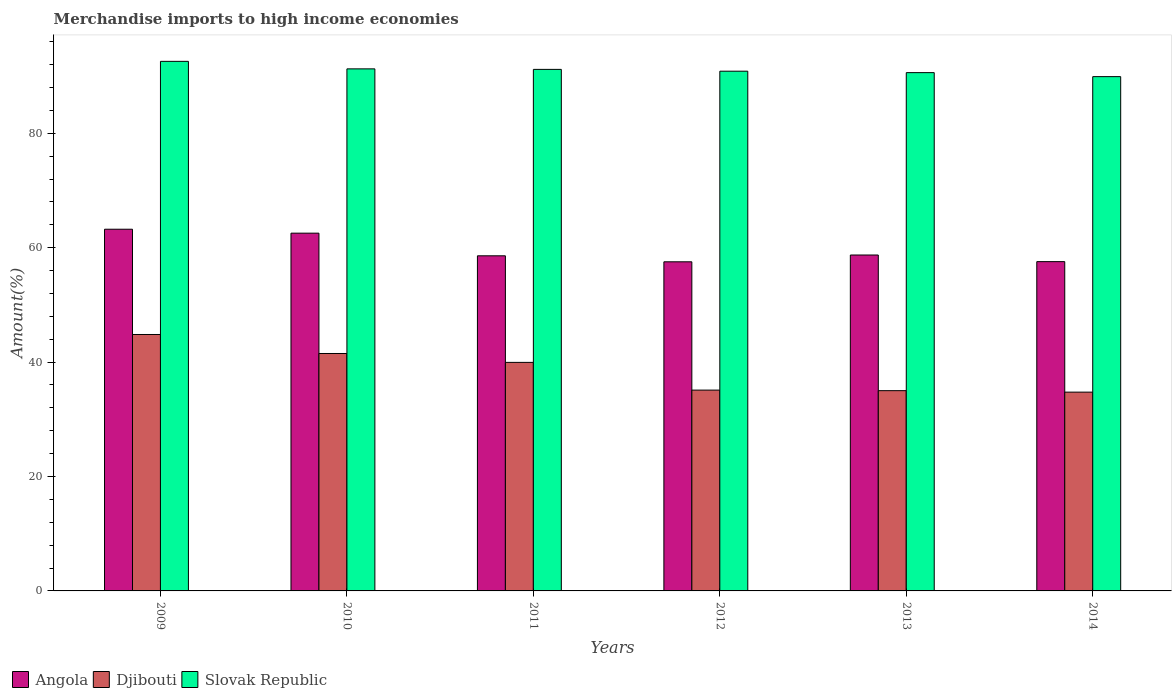How many different coloured bars are there?
Offer a terse response. 3. Are the number of bars per tick equal to the number of legend labels?
Your response must be concise. Yes. Are the number of bars on each tick of the X-axis equal?
Offer a very short reply. Yes. What is the label of the 1st group of bars from the left?
Make the answer very short. 2009. In how many cases, is the number of bars for a given year not equal to the number of legend labels?
Keep it short and to the point. 0. What is the percentage of amount earned from merchandise imports in Slovak Republic in 2013?
Give a very brief answer. 90.61. Across all years, what is the maximum percentage of amount earned from merchandise imports in Slovak Republic?
Make the answer very short. 92.58. Across all years, what is the minimum percentage of amount earned from merchandise imports in Slovak Republic?
Provide a short and direct response. 89.91. In which year was the percentage of amount earned from merchandise imports in Djibouti maximum?
Provide a short and direct response. 2009. In which year was the percentage of amount earned from merchandise imports in Angola minimum?
Ensure brevity in your answer.  2012. What is the total percentage of amount earned from merchandise imports in Angola in the graph?
Make the answer very short. 358.18. What is the difference between the percentage of amount earned from merchandise imports in Angola in 2009 and that in 2012?
Give a very brief answer. 5.7. What is the difference between the percentage of amount earned from merchandise imports in Angola in 2011 and the percentage of amount earned from merchandise imports in Slovak Republic in 2013?
Give a very brief answer. -32.02. What is the average percentage of amount earned from merchandise imports in Slovak Republic per year?
Keep it short and to the point. 91.06. In the year 2010, what is the difference between the percentage of amount earned from merchandise imports in Djibouti and percentage of amount earned from merchandise imports in Slovak Republic?
Ensure brevity in your answer.  -49.76. In how many years, is the percentage of amount earned from merchandise imports in Djibouti greater than 48 %?
Ensure brevity in your answer.  0. What is the ratio of the percentage of amount earned from merchandise imports in Angola in 2009 to that in 2013?
Ensure brevity in your answer.  1.08. Is the percentage of amount earned from merchandise imports in Djibouti in 2010 less than that in 2014?
Make the answer very short. No. Is the difference between the percentage of amount earned from merchandise imports in Djibouti in 2010 and 2012 greater than the difference between the percentage of amount earned from merchandise imports in Slovak Republic in 2010 and 2012?
Your response must be concise. Yes. What is the difference between the highest and the second highest percentage of amount earned from merchandise imports in Djibouti?
Make the answer very short. 3.32. What is the difference between the highest and the lowest percentage of amount earned from merchandise imports in Angola?
Offer a terse response. 5.7. What does the 1st bar from the left in 2010 represents?
Your answer should be very brief. Angola. What does the 2nd bar from the right in 2010 represents?
Your response must be concise. Djibouti. What is the difference between two consecutive major ticks on the Y-axis?
Provide a succinct answer. 20. Does the graph contain any zero values?
Provide a succinct answer. No. Does the graph contain grids?
Your answer should be very brief. No. How many legend labels are there?
Give a very brief answer. 3. How are the legend labels stacked?
Your response must be concise. Horizontal. What is the title of the graph?
Ensure brevity in your answer.  Merchandise imports to high income economies. Does "Sweden" appear as one of the legend labels in the graph?
Give a very brief answer. No. What is the label or title of the X-axis?
Your answer should be very brief. Years. What is the label or title of the Y-axis?
Your answer should be very brief. Amount(%). What is the Amount(%) in Angola in 2009?
Your response must be concise. 63.23. What is the Amount(%) of Djibouti in 2009?
Give a very brief answer. 44.83. What is the Amount(%) in Slovak Republic in 2009?
Ensure brevity in your answer.  92.58. What is the Amount(%) in Angola in 2010?
Your answer should be very brief. 62.54. What is the Amount(%) of Djibouti in 2010?
Offer a terse response. 41.51. What is the Amount(%) in Slovak Republic in 2010?
Your answer should be compact. 91.26. What is the Amount(%) of Angola in 2011?
Provide a short and direct response. 58.58. What is the Amount(%) in Djibouti in 2011?
Your answer should be compact. 39.95. What is the Amount(%) of Slovak Republic in 2011?
Your answer should be compact. 91.17. What is the Amount(%) of Angola in 2012?
Ensure brevity in your answer.  57.53. What is the Amount(%) in Djibouti in 2012?
Give a very brief answer. 35.11. What is the Amount(%) in Slovak Republic in 2012?
Offer a terse response. 90.86. What is the Amount(%) of Angola in 2013?
Provide a short and direct response. 58.72. What is the Amount(%) in Djibouti in 2013?
Offer a very short reply. 35.01. What is the Amount(%) of Slovak Republic in 2013?
Your answer should be compact. 90.61. What is the Amount(%) in Angola in 2014?
Ensure brevity in your answer.  57.57. What is the Amount(%) of Djibouti in 2014?
Keep it short and to the point. 34.75. What is the Amount(%) in Slovak Republic in 2014?
Your answer should be compact. 89.91. Across all years, what is the maximum Amount(%) of Angola?
Your response must be concise. 63.23. Across all years, what is the maximum Amount(%) of Djibouti?
Keep it short and to the point. 44.83. Across all years, what is the maximum Amount(%) in Slovak Republic?
Your response must be concise. 92.58. Across all years, what is the minimum Amount(%) of Angola?
Offer a very short reply. 57.53. Across all years, what is the minimum Amount(%) in Djibouti?
Your answer should be very brief. 34.75. Across all years, what is the minimum Amount(%) of Slovak Republic?
Make the answer very short. 89.91. What is the total Amount(%) in Angola in the graph?
Offer a terse response. 358.18. What is the total Amount(%) in Djibouti in the graph?
Offer a terse response. 231.15. What is the total Amount(%) of Slovak Republic in the graph?
Your answer should be very brief. 546.39. What is the difference between the Amount(%) of Angola in 2009 and that in 2010?
Ensure brevity in your answer.  0.69. What is the difference between the Amount(%) of Djibouti in 2009 and that in 2010?
Give a very brief answer. 3.32. What is the difference between the Amount(%) in Slovak Republic in 2009 and that in 2010?
Provide a short and direct response. 1.31. What is the difference between the Amount(%) of Angola in 2009 and that in 2011?
Make the answer very short. 4.65. What is the difference between the Amount(%) in Djibouti in 2009 and that in 2011?
Your answer should be compact. 4.87. What is the difference between the Amount(%) of Slovak Republic in 2009 and that in 2011?
Give a very brief answer. 1.4. What is the difference between the Amount(%) in Angola in 2009 and that in 2012?
Offer a terse response. 5.7. What is the difference between the Amount(%) in Djibouti in 2009 and that in 2012?
Your response must be concise. 9.72. What is the difference between the Amount(%) of Slovak Republic in 2009 and that in 2012?
Offer a terse response. 1.72. What is the difference between the Amount(%) in Angola in 2009 and that in 2013?
Provide a succinct answer. 4.51. What is the difference between the Amount(%) in Djibouti in 2009 and that in 2013?
Keep it short and to the point. 9.82. What is the difference between the Amount(%) in Slovak Republic in 2009 and that in 2013?
Offer a very short reply. 1.97. What is the difference between the Amount(%) of Angola in 2009 and that in 2014?
Provide a succinct answer. 5.66. What is the difference between the Amount(%) in Djibouti in 2009 and that in 2014?
Make the answer very short. 10.08. What is the difference between the Amount(%) in Slovak Republic in 2009 and that in 2014?
Provide a short and direct response. 2.67. What is the difference between the Amount(%) in Angola in 2010 and that in 2011?
Provide a succinct answer. 3.96. What is the difference between the Amount(%) in Djibouti in 2010 and that in 2011?
Provide a succinct answer. 1.55. What is the difference between the Amount(%) of Slovak Republic in 2010 and that in 2011?
Offer a very short reply. 0.09. What is the difference between the Amount(%) in Angola in 2010 and that in 2012?
Your answer should be compact. 5.01. What is the difference between the Amount(%) of Djibouti in 2010 and that in 2012?
Provide a succinct answer. 6.4. What is the difference between the Amount(%) in Slovak Republic in 2010 and that in 2012?
Give a very brief answer. 0.41. What is the difference between the Amount(%) of Angola in 2010 and that in 2013?
Ensure brevity in your answer.  3.82. What is the difference between the Amount(%) in Djibouti in 2010 and that in 2013?
Your answer should be compact. 6.5. What is the difference between the Amount(%) of Slovak Republic in 2010 and that in 2013?
Offer a very short reply. 0.66. What is the difference between the Amount(%) of Angola in 2010 and that in 2014?
Ensure brevity in your answer.  4.98. What is the difference between the Amount(%) of Djibouti in 2010 and that in 2014?
Make the answer very short. 6.76. What is the difference between the Amount(%) of Slovak Republic in 2010 and that in 2014?
Your answer should be compact. 1.36. What is the difference between the Amount(%) of Angola in 2011 and that in 2012?
Your answer should be compact. 1.05. What is the difference between the Amount(%) of Djibouti in 2011 and that in 2012?
Your response must be concise. 4.85. What is the difference between the Amount(%) in Slovak Republic in 2011 and that in 2012?
Your answer should be compact. 0.32. What is the difference between the Amount(%) of Angola in 2011 and that in 2013?
Ensure brevity in your answer.  -0.14. What is the difference between the Amount(%) in Djibouti in 2011 and that in 2013?
Your answer should be very brief. 4.95. What is the difference between the Amount(%) of Slovak Republic in 2011 and that in 2013?
Your answer should be compact. 0.57. What is the difference between the Amount(%) in Angola in 2011 and that in 2014?
Your answer should be compact. 1.02. What is the difference between the Amount(%) in Djibouti in 2011 and that in 2014?
Provide a short and direct response. 5.2. What is the difference between the Amount(%) in Slovak Republic in 2011 and that in 2014?
Your answer should be very brief. 1.27. What is the difference between the Amount(%) in Angola in 2012 and that in 2013?
Give a very brief answer. -1.19. What is the difference between the Amount(%) of Djibouti in 2012 and that in 2013?
Your answer should be very brief. 0.1. What is the difference between the Amount(%) of Slovak Republic in 2012 and that in 2013?
Offer a very short reply. 0.25. What is the difference between the Amount(%) in Angola in 2012 and that in 2014?
Keep it short and to the point. -0.03. What is the difference between the Amount(%) of Djibouti in 2012 and that in 2014?
Offer a terse response. 0.35. What is the difference between the Amount(%) in Slovak Republic in 2012 and that in 2014?
Provide a short and direct response. 0.95. What is the difference between the Amount(%) of Angola in 2013 and that in 2014?
Provide a succinct answer. 1.16. What is the difference between the Amount(%) in Djibouti in 2013 and that in 2014?
Make the answer very short. 0.26. What is the difference between the Amount(%) of Slovak Republic in 2013 and that in 2014?
Ensure brevity in your answer.  0.7. What is the difference between the Amount(%) of Angola in 2009 and the Amount(%) of Djibouti in 2010?
Provide a succinct answer. 21.72. What is the difference between the Amount(%) in Angola in 2009 and the Amount(%) in Slovak Republic in 2010?
Ensure brevity in your answer.  -28.03. What is the difference between the Amount(%) of Djibouti in 2009 and the Amount(%) of Slovak Republic in 2010?
Keep it short and to the point. -46.44. What is the difference between the Amount(%) of Angola in 2009 and the Amount(%) of Djibouti in 2011?
Offer a very short reply. 23.28. What is the difference between the Amount(%) in Angola in 2009 and the Amount(%) in Slovak Republic in 2011?
Keep it short and to the point. -27.94. What is the difference between the Amount(%) of Djibouti in 2009 and the Amount(%) of Slovak Republic in 2011?
Your response must be concise. -46.35. What is the difference between the Amount(%) of Angola in 2009 and the Amount(%) of Djibouti in 2012?
Give a very brief answer. 28.12. What is the difference between the Amount(%) of Angola in 2009 and the Amount(%) of Slovak Republic in 2012?
Provide a succinct answer. -27.63. What is the difference between the Amount(%) in Djibouti in 2009 and the Amount(%) in Slovak Republic in 2012?
Make the answer very short. -46.03. What is the difference between the Amount(%) of Angola in 2009 and the Amount(%) of Djibouti in 2013?
Your response must be concise. 28.22. What is the difference between the Amount(%) in Angola in 2009 and the Amount(%) in Slovak Republic in 2013?
Provide a short and direct response. -27.38. What is the difference between the Amount(%) of Djibouti in 2009 and the Amount(%) of Slovak Republic in 2013?
Offer a very short reply. -45.78. What is the difference between the Amount(%) in Angola in 2009 and the Amount(%) in Djibouti in 2014?
Provide a short and direct response. 28.48. What is the difference between the Amount(%) of Angola in 2009 and the Amount(%) of Slovak Republic in 2014?
Offer a terse response. -26.68. What is the difference between the Amount(%) in Djibouti in 2009 and the Amount(%) in Slovak Republic in 2014?
Your response must be concise. -45.08. What is the difference between the Amount(%) of Angola in 2010 and the Amount(%) of Djibouti in 2011?
Provide a short and direct response. 22.59. What is the difference between the Amount(%) in Angola in 2010 and the Amount(%) in Slovak Republic in 2011?
Provide a succinct answer. -28.63. What is the difference between the Amount(%) in Djibouti in 2010 and the Amount(%) in Slovak Republic in 2011?
Ensure brevity in your answer.  -49.67. What is the difference between the Amount(%) of Angola in 2010 and the Amount(%) of Djibouti in 2012?
Offer a very short reply. 27.43. What is the difference between the Amount(%) in Angola in 2010 and the Amount(%) in Slovak Republic in 2012?
Make the answer very short. -28.32. What is the difference between the Amount(%) in Djibouti in 2010 and the Amount(%) in Slovak Republic in 2012?
Provide a succinct answer. -49.35. What is the difference between the Amount(%) in Angola in 2010 and the Amount(%) in Djibouti in 2013?
Make the answer very short. 27.53. What is the difference between the Amount(%) of Angola in 2010 and the Amount(%) of Slovak Republic in 2013?
Your answer should be very brief. -28.07. What is the difference between the Amount(%) in Djibouti in 2010 and the Amount(%) in Slovak Republic in 2013?
Your response must be concise. -49.1. What is the difference between the Amount(%) of Angola in 2010 and the Amount(%) of Djibouti in 2014?
Ensure brevity in your answer.  27.79. What is the difference between the Amount(%) in Angola in 2010 and the Amount(%) in Slovak Republic in 2014?
Keep it short and to the point. -27.37. What is the difference between the Amount(%) in Djibouti in 2010 and the Amount(%) in Slovak Republic in 2014?
Your answer should be very brief. -48.4. What is the difference between the Amount(%) in Angola in 2011 and the Amount(%) in Djibouti in 2012?
Give a very brief answer. 23.48. What is the difference between the Amount(%) in Angola in 2011 and the Amount(%) in Slovak Republic in 2012?
Make the answer very short. -32.27. What is the difference between the Amount(%) of Djibouti in 2011 and the Amount(%) of Slovak Republic in 2012?
Your answer should be compact. -50.9. What is the difference between the Amount(%) in Angola in 2011 and the Amount(%) in Djibouti in 2013?
Your answer should be very brief. 23.58. What is the difference between the Amount(%) in Angola in 2011 and the Amount(%) in Slovak Republic in 2013?
Offer a very short reply. -32.02. What is the difference between the Amount(%) in Djibouti in 2011 and the Amount(%) in Slovak Republic in 2013?
Offer a very short reply. -50.65. What is the difference between the Amount(%) in Angola in 2011 and the Amount(%) in Djibouti in 2014?
Provide a short and direct response. 23.83. What is the difference between the Amount(%) of Angola in 2011 and the Amount(%) of Slovak Republic in 2014?
Keep it short and to the point. -31.32. What is the difference between the Amount(%) in Djibouti in 2011 and the Amount(%) in Slovak Republic in 2014?
Offer a terse response. -49.95. What is the difference between the Amount(%) of Angola in 2012 and the Amount(%) of Djibouti in 2013?
Your answer should be compact. 22.53. What is the difference between the Amount(%) in Angola in 2012 and the Amount(%) in Slovak Republic in 2013?
Offer a very short reply. -33.07. What is the difference between the Amount(%) of Djibouti in 2012 and the Amount(%) of Slovak Republic in 2013?
Your answer should be very brief. -55.5. What is the difference between the Amount(%) in Angola in 2012 and the Amount(%) in Djibouti in 2014?
Your response must be concise. 22.78. What is the difference between the Amount(%) of Angola in 2012 and the Amount(%) of Slovak Republic in 2014?
Provide a succinct answer. -32.37. What is the difference between the Amount(%) in Djibouti in 2012 and the Amount(%) in Slovak Republic in 2014?
Provide a short and direct response. -54.8. What is the difference between the Amount(%) in Angola in 2013 and the Amount(%) in Djibouti in 2014?
Your response must be concise. 23.97. What is the difference between the Amount(%) in Angola in 2013 and the Amount(%) in Slovak Republic in 2014?
Your answer should be compact. -31.18. What is the difference between the Amount(%) of Djibouti in 2013 and the Amount(%) of Slovak Republic in 2014?
Offer a terse response. -54.9. What is the average Amount(%) in Angola per year?
Ensure brevity in your answer.  59.7. What is the average Amount(%) of Djibouti per year?
Your response must be concise. 38.53. What is the average Amount(%) of Slovak Republic per year?
Ensure brevity in your answer.  91.06. In the year 2009, what is the difference between the Amount(%) of Angola and Amount(%) of Djibouti?
Keep it short and to the point. 18.4. In the year 2009, what is the difference between the Amount(%) of Angola and Amount(%) of Slovak Republic?
Provide a succinct answer. -29.35. In the year 2009, what is the difference between the Amount(%) of Djibouti and Amount(%) of Slovak Republic?
Provide a succinct answer. -47.75. In the year 2010, what is the difference between the Amount(%) in Angola and Amount(%) in Djibouti?
Ensure brevity in your answer.  21.03. In the year 2010, what is the difference between the Amount(%) of Angola and Amount(%) of Slovak Republic?
Provide a short and direct response. -28.72. In the year 2010, what is the difference between the Amount(%) of Djibouti and Amount(%) of Slovak Republic?
Provide a short and direct response. -49.76. In the year 2011, what is the difference between the Amount(%) in Angola and Amount(%) in Djibouti?
Your answer should be very brief. 18.63. In the year 2011, what is the difference between the Amount(%) of Angola and Amount(%) of Slovak Republic?
Ensure brevity in your answer.  -32.59. In the year 2011, what is the difference between the Amount(%) in Djibouti and Amount(%) in Slovak Republic?
Give a very brief answer. -51.22. In the year 2012, what is the difference between the Amount(%) in Angola and Amount(%) in Djibouti?
Make the answer very short. 22.43. In the year 2012, what is the difference between the Amount(%) in Angola and Amount(%) in Slovak Republic?
Your answer should be compact. -33.32. In the year 2012, what is the difference between the Amount(%) of Djibouti and Amount(%) of Slovak Republic?
Provide a succinct answer. -55.75. In the year 2013, what is the difference between the Amount(%) in Angola and Amount(%) in Djibouti?
Ensure brevity in your answer.  23.72. In the year 2013, what is the difference between the Amount(%) of Angola and Amount(%) of Slovak Republic?
Keep it short and to the point. -31.88. In the year 2013, what is the difference between the Amount(%) in Djibouti and Amount(%) in Slovak Republic?
Make the answer very short. -55.6. In the year 2014, what is the difference between the Amount(%) in Angola and Amount(%) in Djibouti?
Provide a short and direct response. 22.81. In the year 2014, what is the difference between the Amount(%) of Angola and Amount(%) of Slovak Republic?
Your answer should be very brief. -32.34. In the year 2014, what is the difference between the Amount(%) in Djibouti and Amount(%) in Slovak Republic?
Offer a very short reply. -55.16. What is the ratio of the Amount(%) in Angola in 2009 to that in 2010?
Keep it short and to the point. 1.01. What is the ratio of the Amount(%) of Djibouti in 2009 to that in 2010?
Make the answer very short. 1.08. What is the ratio of the Amount(%) in Slovak Republic in 2009 to that in 2010?
Offer a terse response. 1.01. What is the ratio of the Amount(%) in Angola in 2009 to that in 2011?
Make the answer very short. 1.08. What is the ratio of the Amount(%) in Djibouti in 2009 to that in 2011?
Offer a terse response. 1.12. What is the ratio of the Amount(%) in Slovak Republic in 2009 to that in 2011?
Provide a short and direct response. 1.02. What is the ratio of the Amount(%) in Angola in 2009 to that in 2012?
Offer a terse response. 1.1. What is the ratio of the Amount(%) in Djibouti in 2009 to that in 2012?
Offer a very short reply. 1.28. What is the ratio of the Amount(%) in Slovak Republic in 2009 to that in 2012?
Provide a short and direct response. 1.02. What is the ratio of the Amount(%) in Angola in 2009 to that in 2013?
Keep it short and to the point. 1.08. What is the ratio of the Amount(%) in Djibouti in 2009 to that in 2013?
Keep it short and to the point. 1.28. What is the ratio of the Amount(%) in Slovak Republic in 2009 to that in 2013?
Ensure brevity in your answer.  1.02. What is the ratio of the Amount(%) of Angola in 2009 to that in 2014?
Your answer should be very brief. 1.1. What is the ratio of the Amount(%) in Djibouti in 2009 to that in 2014?
Provide a succinct answer. 1.29. What is the ratio of the Amount(%) of Slovak Republic in 2009 to that in 2014?
Offer a terse response. 1.03. What is the ratio of the Amount(%) of Angola in 2010 to that in 2011?
Make the answer very short. 1.07. What is the ratio of the Amount(%) in Djibouti in 2010 to that in 2011?
Your answer should be very brief. 1.04. What is the ratio of the Amount(%) of Slovak Republic in 2010 to that in 2011?
Your answer should be compact. 1. What is the ratio of the Amount(%) of Angola in 2010 to that in 2012?
Ensure brevity in your answer.  1.09. What is the ratio of the Amount(%) of Djibouti in 2010 to that in 2012?
Your answer should be compact. 1.18. What is the ratio of the Amount(%) in Slovak Republic in 2010 to that in 2012?
Provide a succinct answer. 1. What is the ratio of the Amount(%) of Angola in 2010 to that in 2013?
Provide a succinct answer. 1.06. What is the ratio of the Amount(%) of Djibouti in 2010 to that in 2013?
Make the answer very short. 1.19. What is the ratio of the Amount(%) in Angola in 2010 to that in 2014?
Give a very brief answer. 1.09. What is the ratio of the Amount(%) in Djibouti in 2010 to that in 2014?
Keep it short and to the point. 1.19. What is the ratio of the Amount(%) of Slovak Republic in 2010 to that in 2014?
Your answer should be compact. 1.02. What is the ratio of the Amount(%) of Angola in 2011 to that in 2012?
Your answer should be very brief. 1.02. What is the ratio of the Amount(%) of Djibouti in 2011 to that in 2012?
Your answer should be very brief. 1.14. What is the ratio of the Amount(%) of Slovak Republic in 2011 to that in 2012?
Offer a very short reply. 1. What is the ratio of the Amount(%) of Djibouti in 2011 to that in 2013?
Your answer should be compact. 1.14. What is the ratio of the Amount(%) of Angola in 2011 to that in 2014?
Make the answer very short. 1.02. What is the ratio of the Amount(%) in Djibouti in 2011 to that in 2014?
Provide a short and direct response. 1.15. What is the ratio of the Amount(%) of Slovak Republic in 2011 to that in 2014?
Your answer should be compact. 1.01. What is the ratio of the Amount(%) of Angola in 2012 to that in 2013?
Offer a very short reply. 0.98. What is the ratio of the Amount(%) of Djibouti in 2012 to that in 2014?
Your answer should be very brief. 1.01. What is the ratio of the Amount(%) of Slovak Republic in 2012 to that in 2014?
Offer a very short reply. 1.01. What is the ratio of the Amount(%) of Angola in 2013 to that in 2014?
Keep it short and to the point. 1.02. What is the ratio of the Amount(%) in Djibouti in 2013 to that in 2014?
Give a very brief answer. 1.01. What is the difference between the highest and the second highest Amount(%) in Angola?
Keep it short and to the point. 0.69. What is the difference between the highest and the second highest Amount(%) in Djibouti?
Provide a succinct answer. 3.32. What is the difference between the highest and the second highest Amount(%) in Slovak Republic?
Your response must be concise. 1.31. What is the difference between the highest and the lowest Amount(%) of Angola?
Keep it short and to the point. 5.7. What is the difference between the highest and the lowest Amount(%) in Djibouti?
Make the answer very short. 10.08. What is the difference between the highest and the lowest Amount(%) in Slovak Republic?
Your response must be concise. 2.67. 